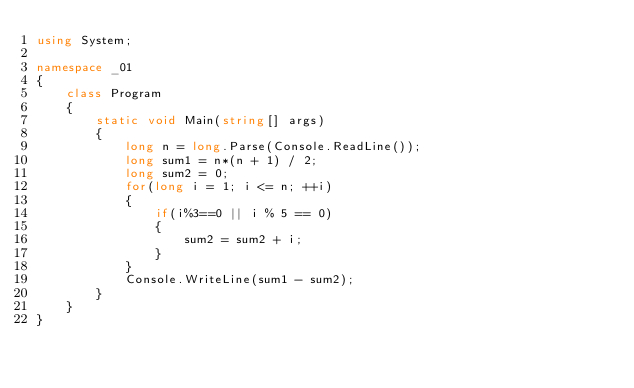<code> <loc_0><loc_0><loc_500><loc_500><_C#_>using System;

namespace _01
{
    class Program
    {
        static void Main(string[] args)
        {
            long n = long.Parse(Console.ReadLine());
            long sum1 = n*(n + 1) / 2;
            long sum2 = 0;
            for(long i = 1; i <= n; ++i)
            {
                if(i%3==0 || i % 5 == 0)
                {
                    sum2 = sum2 + i;
                }
            }
            Console.WriteLine(sum1 - sum2);
        }
    }
}
</code> 